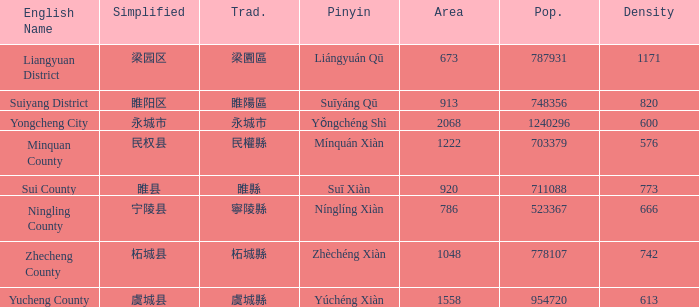What is the traditional form for 永城市? 永城市. 